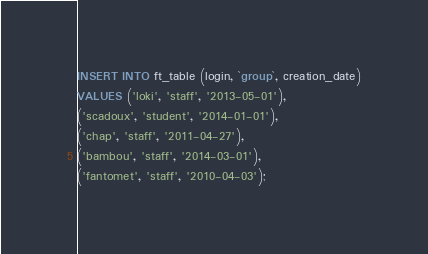Convert code to text. <code><loc_0><loc_0><loc_500><loc_500><_SQL_>INSERT INTO ft_table (login, `group`, creation_date)
VALUES ('loki', 'staff', '2013-05-01'),
('scadoux', 'student', '2014-01-01'),
('chap', 'staff', '2011-04-27'),
('bambou', 'staff', '2014-03-01'),
('fantomet', 'staff', '2010-04-03');
</code> 